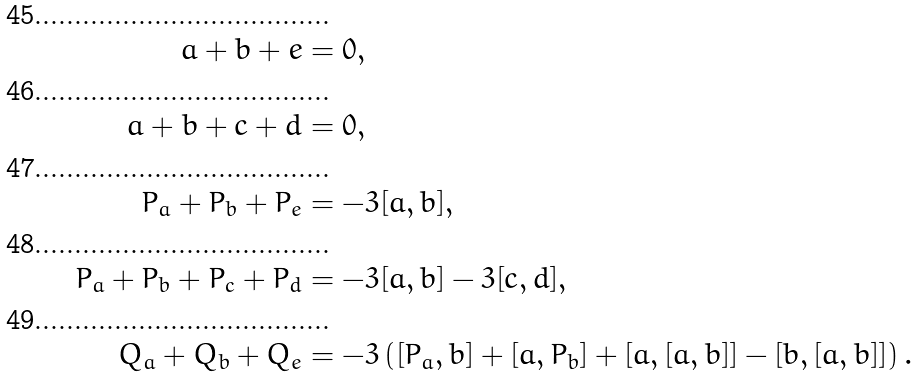<formula> <loc_0><loc_0><loc_500><loc_500>a + b + e & = 0 , \\ a + b + c + d & = 0 , \\ P _ { a } + P _ { b } + P _ { e } & = - 3 [ a , b ] , \\ \, P _ { a } + P _ { b } + P _ { c } + P _ { d } & = - 3 [ a , b ] - 3 [ c , d ] , \\ \, Q _ { a } + Q _ { b } + Q _ { e } & = - 3 \left ( [ P _ { a } , b ] + [ a , P _ { b } ] + [ a , [ a , b ] ] - [ b , [ a , b ] ] \right ) .</formula> 